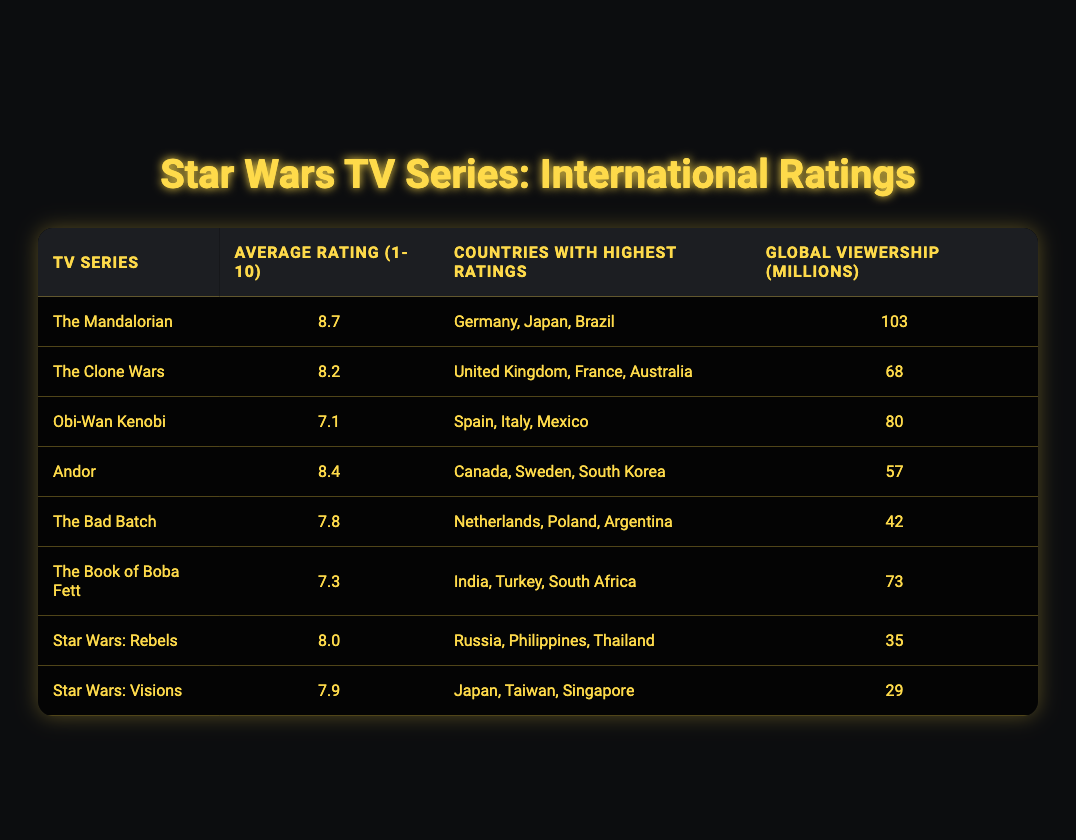What is the highest-rated Star Wars TV series? By looking at the "Average Rating (1-10)" column, "The Mandalorian" has the highest rating of 8.7.
Answer: The Mandalorian Which series has a higher rating: The Clone Wars or Andor? The Clone Wars has a rating of 8.2, while Andor has a rating of 8.4. Since 8.4 is greater than 8.2, Andor has a higher rating.
Answer: Andor Are there more millions of global viewers for The Book of Boba Fett than for Star Wars: Visions? The Book of Boba Fett has 73 million viewers, while Star Wars: Visions has 29 million viewers. Since 73 is greater than 29, the answer is yes.
Answer: Yes What is the total global viewership (in millions) of The Bad Batch and Obi-Wan Kenobi combined? The viewership of The Bad Batch is 42 million, and for Obi-Wan Kenobi, it is 80 million. Adding these together gives 42 + 80 = 122 million.
Answer: 122 Which country is listed as having the highest ratings for Obi-Wan Kenobi? The countries listed for the highest ratings of Obi-Wan Kenobi are Spain, Italy, and Mexico. The first country listed is Spain.
Answer: Spain Calculate the average rating of the shows that feature a rating above 8.0. The shows with ratings above 8.0 are The Mandalorian (8.7), The Clone Wars (8.2), Andor (8.4), and Star Wars: Rebels (8.0). Adding these ratings gives 8.7 + 8.2 + 8.4 + 8.0 = 33.3. There are 4 shows, so the average is 33.3 / 4 = 8.325.
Answer: 8.325 Do Japan and Canada both appear as countries with high ratings? Japan is listed under The Mandalorian and Star Wars: Visions, while Canada is listed under Andor. Since both countries appear under the series, the answer is yes.
Answer: Yes Which show has the least amount of global viewership? By looking at the "Global Viewership (millions)" column, Star Wars: Visions has the lowest at 29 million.
Answer: Star Wars: Visions 